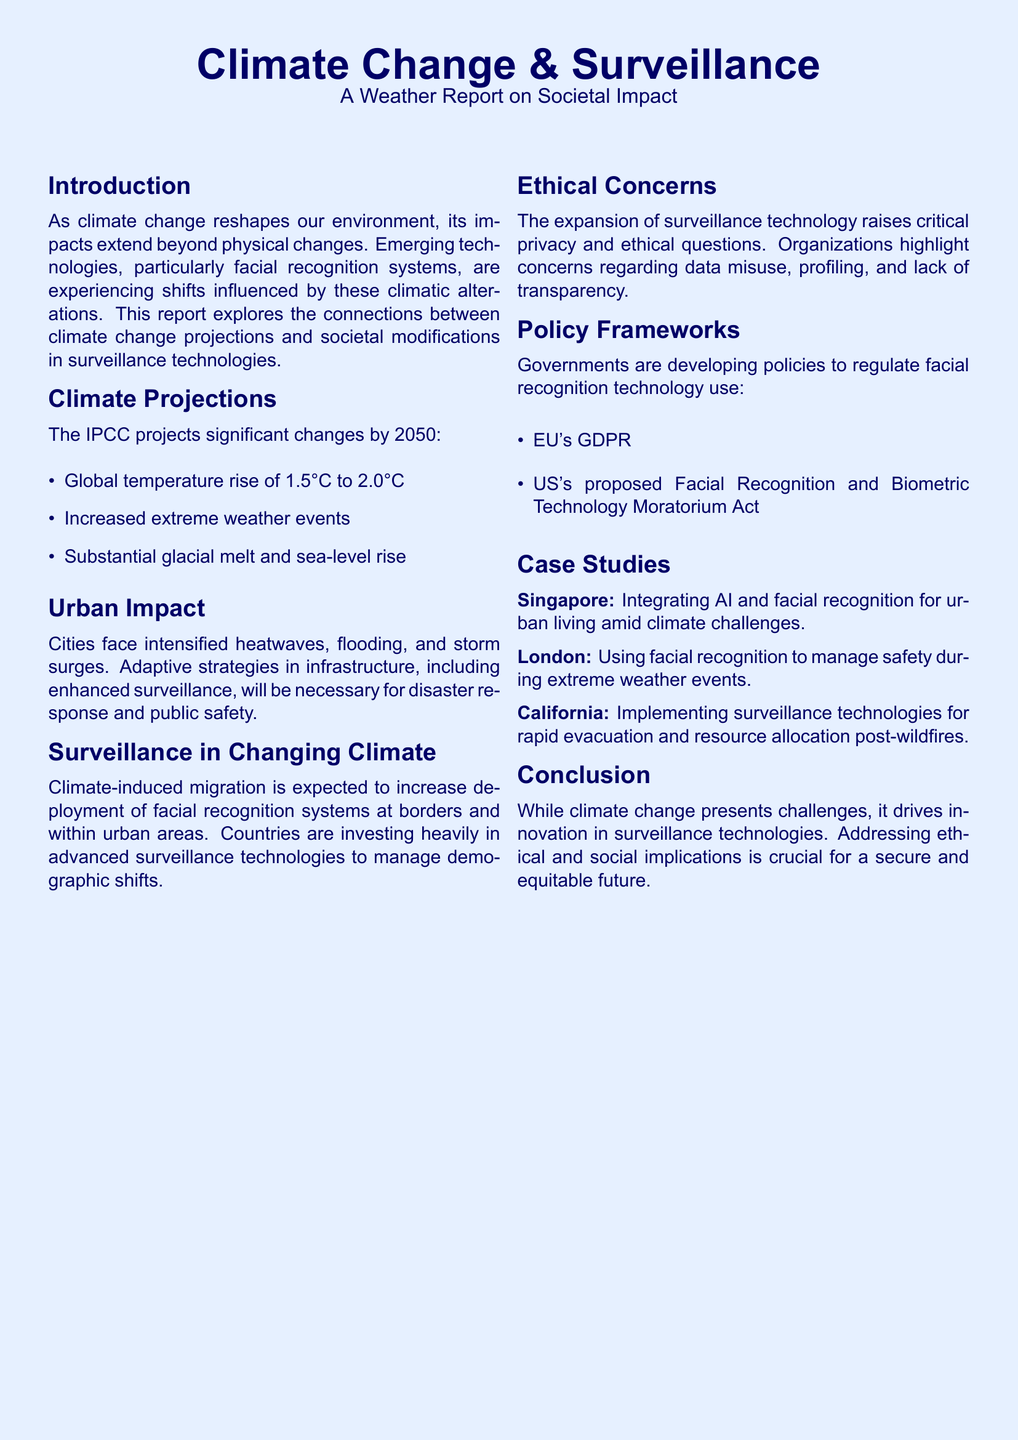What is the expected global temperature rise by 2050? The document states the projected temperature rise as between 1.5°C and 2.0°C by 2050.
Answer: 1.5°C to 2.0°C What significant urban problem is mentioned in the report? The report highlights intensified heatwaves, flooding, and storm surges as significant urban problems.
Answer: Heatwaves, flooding, and storm surges Which country is mentioned as integrating AI and facial recognition? The report specifically mentions Singapore as an example of this integration amid climate challenges.
Answer: Singapore What ethical concern is raised regarding surveillance technology? The document mentions data misuse, profiling, and lack of transparency as ethical concerns.
Answer: Data misuse, profiling, and lack of transparency What is one of the policies being developed in the EU? The European Union is developing the General Data Protection Regulation (GDPR) as mentioned in the document.
Answer: GDPR Which act is proposed in the US regarding facial recognition? The document refers to the proposed Facial Recognition and Biometric Technology Moratorium Act in the United States.
Answer: Facial Recognition and Biometric Technology Moratorium Act What are countries investing heavily in due to climate-induced migration? The report discusses increased investment in advanced surveillance technologies as a response to demographic shifts.
Answer: Advanced surveillance technologies How does the report conclude about the relationship between climate change and surveillance? The conclusion states that while challenges are presented by climate change, it drives innovation in surveillance technologies.
Answer: Drives innovation in surveillance technologies 